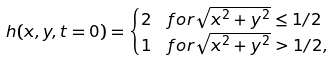Convert formula to latex. <formula><loc_0><loc_0><loc_500><loc_500>h ( x , y , t = 0 ) & = \begin{cases} 2 & f o r \sqrt { x ^ { 2 } + y ^ { 2 } } \leq 1 / 2 \\ 1 & f o r \sqrt { x ^ { 2 } + y ^ { 2 } } > 1 / 2 , \end{cases}</formula> 